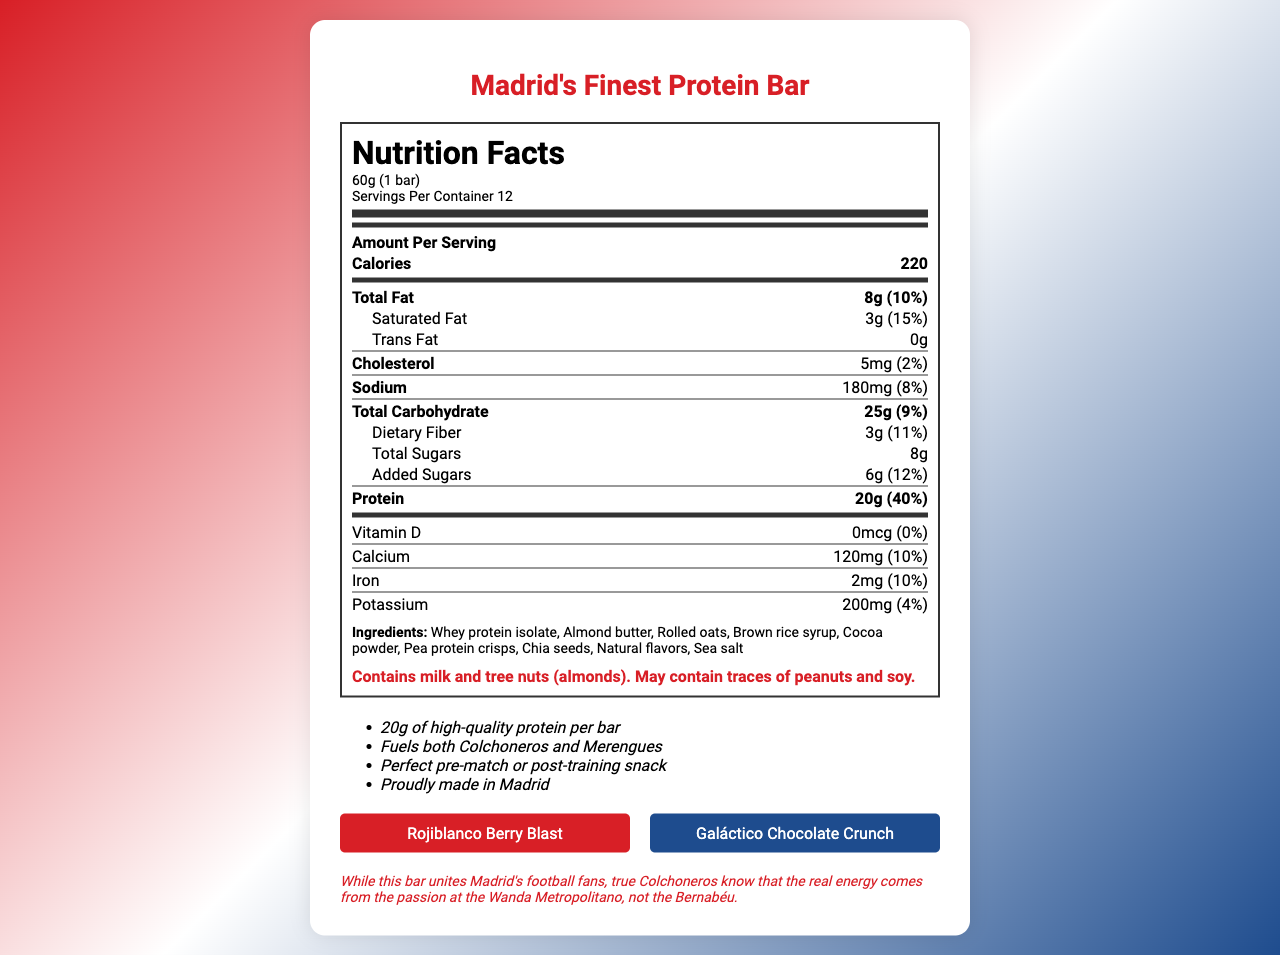what is the serving size? The serving size is listed at the top of the Nutrition Facts section as "60g (1 bar)."
Answer: 60g (1 bar) how many servings per container are there? The document states "Servings Per Container 12" under the serving size information.
Answer: 12 how many calories are in one serving? The calorie count is listed as 220 in the bolded section for "Calories" under the "Amount Per Serving" section.
Answer: 220 what is the total fat content per serving? Under "Total Fat," the amount is specified as 8g with a daily value of 10%.
Answer: 8g what allergens are present in this product? This information is listed at the end of the ingredient list with highlighted red text.
Answer: Contains milk and tree nuts (almonds). May contain traces of peanuts and soy. how much protein is in one bar of "Madrid's Finest Protein Bar"? The protein content is clearly stated in bold as "20g" with a daily value of 40%.
Answer: 20g what flavor is inspired by Atletico Madrid? This information is specified under the flavors section at the bottom of the document.
Answer: Rojiblanco Berry Blast which of the following is an ingredient in "Madrid's Finest Protein Bar"?
A. Soy protein isolate
B. Almond butter
C. Egg whites
D. Olive oil The ingredient list includes "Almond butter," but not soy protein isolate, egg whites, or olive oil.
Answer: B. Almond butter how much added sugars are in this protein bar? A. 4g B. 6g C. 8g D. 10g Under "Added Sugars," the amount listed is "6g" with a daily value of 12%.
Answer: B. 6g does this bar contain any trans fat? The trans fat amount is listed as "0g."
Answer: No what is the daily value percentage of dietary fiber in this protein bar? The daily value percentage for dietary fiber is listed as 11%.
Answer: 11% which nutrient has the highest daily value percentage? A. Protein B. Total Carbohydrate C. Total Fat D. Sodium Protein has a daily value percentage of 40%, which is higher than total carbohydrate (9%), total fat (10%), and sodium (8%).
Answer: A. Protein what are some of the marketing claims made about this protein bar? The marketing claims are listed under the marketing claims section and include these specific points.
Answer: 20g of high-quality protein per bar, Fuels both Colchoneros and Merengues, Perfect pre-match or post-training snack, Proudly made in Madrid what is the special note mentioned in the document? This special note is listed at the bottom of the document.
Answer: While this bar unites Madrid's football fans, true Colchoneros know that the real energy comes from the passion at the Wanda Metropolitano, not the Bernabéu. what vitamin has a daily value percentage of 0%? The document indicates that Vitamin D has 0mcg and a 0% daily value percentage.
Answer: Vitamin D how many grams of saturated fat are present per serving? The saturated fat content is listed as 3g with a daily value of 15%.
Answer: 3g summarize the nutritional information and features of "Madrid's Finest Protein Bar." The explanation summarizes all the nutritional information and notable features mentioned in the document.
Answer: This document provides detailed nutritional information for "Madrid's Finest Protein Bar," including a serving size of 60g (1 bar) and 12 servings per container. Each serving contains 220 calories and 20g of protein (40% daily value). The total fat is 8g (10% daily value), with 3g of saturated fat (15% daily value) and 0g of trans fat. It also contains 5mg of cholesterol (2% daily value), 180mg of sodium (8% daily value), 25g of total carbohydrates (9% daily value), 3g of dietary fiber (11% daily value), and 8g of total sugars, including 6g of added sugars (12% daily value). The bar is fortified with calcium (10% daily value), iron (10% daily value), and potassium (4% daily value) but contains no Vitamin D. It includes ingredients like whey protein isolate, almond butter, and rolled oats. Allergen information notes the presence of milk and tree nuts (almonds), with potential traces of peanuts and soy. Marketing claims highlight its 20g of high-quality protein per bar and appeal to both Atletico and Real Madrid supporters. The bar comes in two flavors: "Rojiblanco Berry Blast" for Atletico fans and "Galáctico Chocolate Crunch" for Real Madrid fans, with a special note emphasizing the passion of true Colchoneros. who owns the company that produces "Madrid's Finest Protein Bar"? The document does not provide any information regarding the ownership of the company that produces the protein bar.
Answer: Cannot be determined 